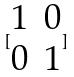Convert formula to latex. <formula><loc_0><loc_0><loc_500><loc_500>[ \begin{matrix} 1 & 0 \\ 0 & 1 \end{matrix} ]</formula> 